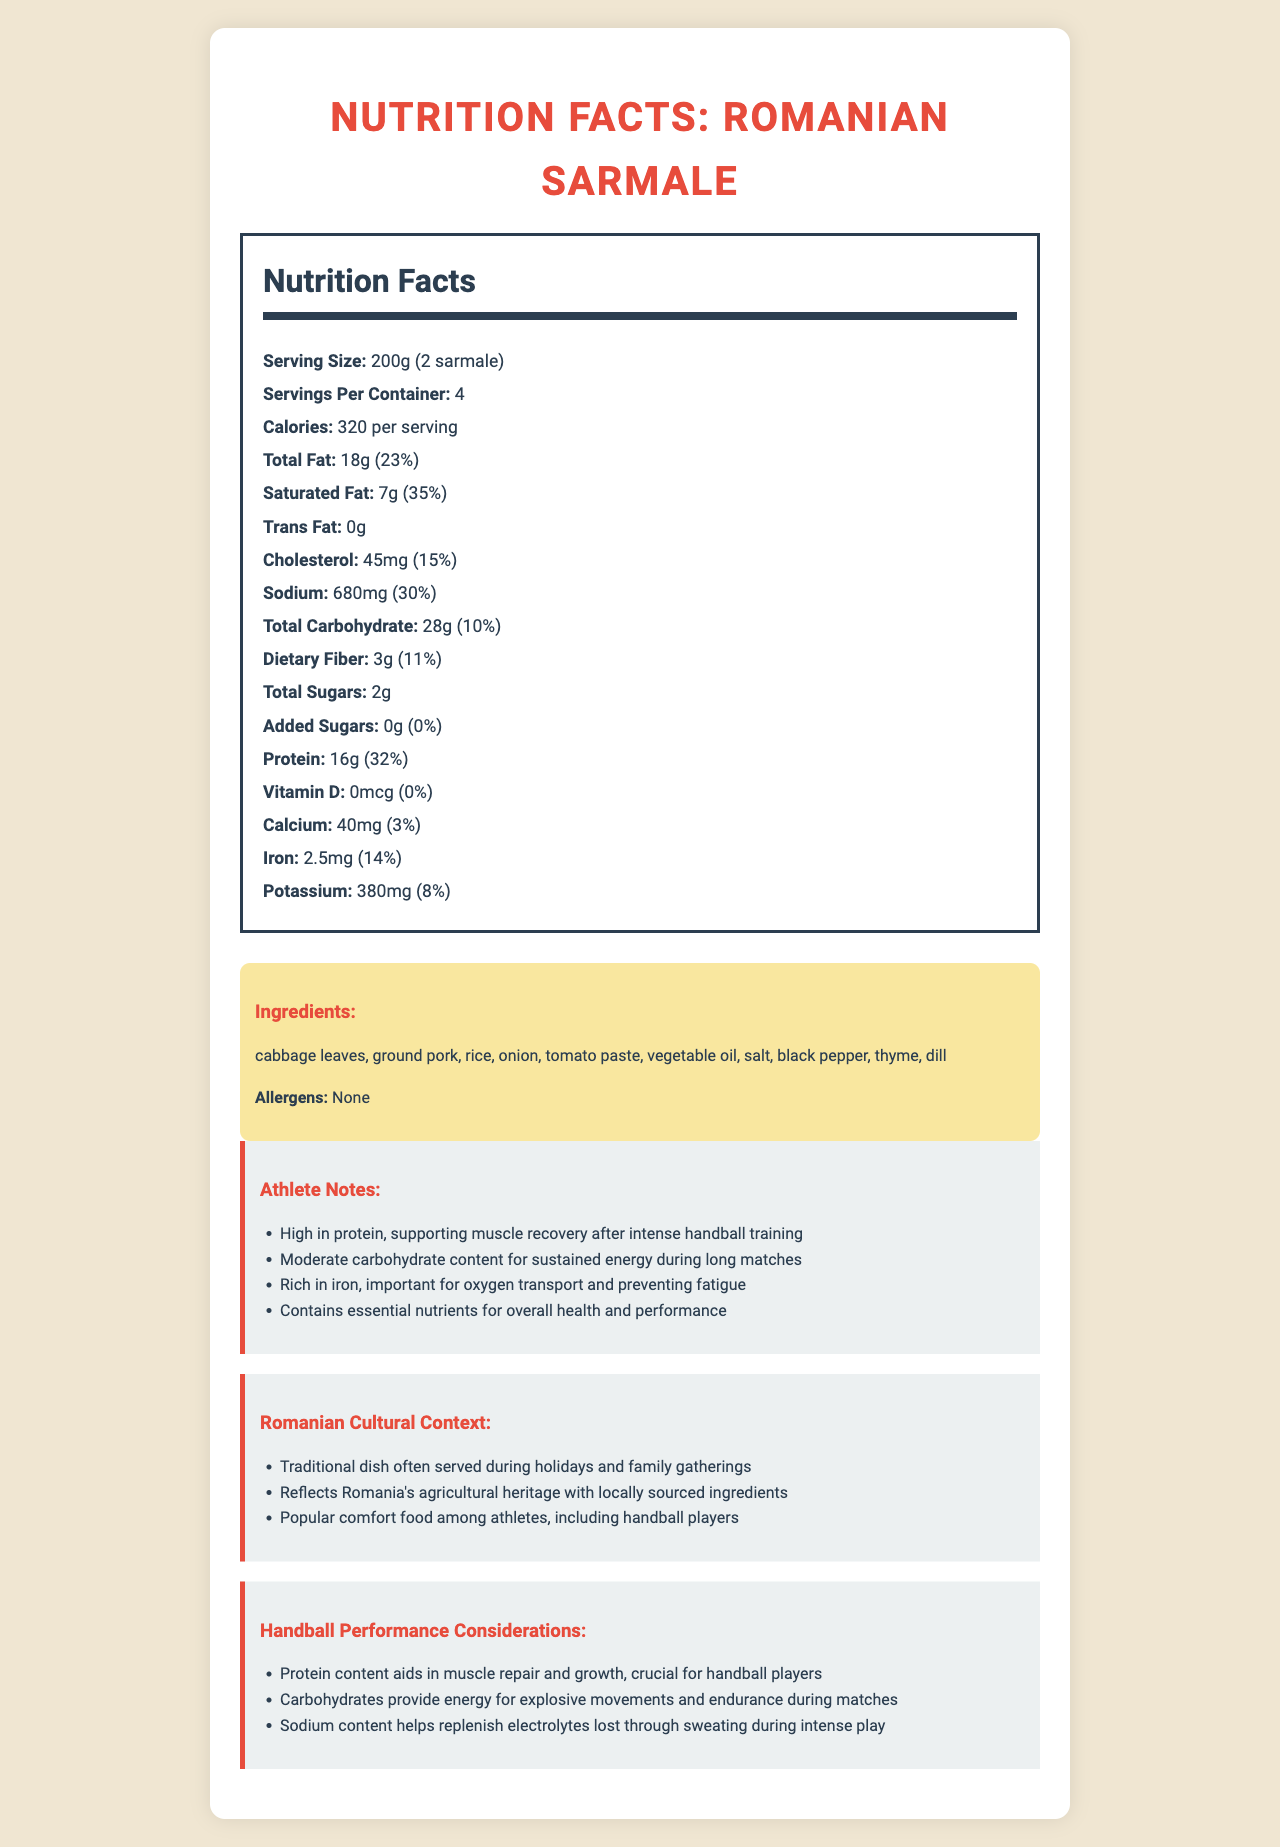what is the serving size for the sarmale dish? The document states that the serving size is 200g, which is equivalent to 2 sarmale.
Answer: 200g (2 sarmale) how much protein does one serving of the sarmale dish contain? The document specifically lists that one serving of the sarmale dish contains 16g of protein.
Answer: 16g What is the total carbohydrate content per serving? The document indicates that the total carbohydrate content per serving is 28g.
Answer: 28g what percentage of the daily value (%DV) for carbohydrates does one serving provide? The document states that the total carbohydrate content per serving contributes to 10% of the daily value.
Answer: 10% how much dietary fiber is present in one serving of the sarmale dish? The dietary fiber content per serving is listed as 3g in the document.
Answer: 3g what are the primary ingredients in the traditional Romanian sarmale dish? The document lists the primary ingredients as cabbage leaves, ground pork, rice, onion, tomato paste, vegetable oil, salt, black pepper, thyme, and dill.
Answer: cabbage leaves, ground pork, rice, onion, tomato paste, vegetable oil, salt, black pepper, thyme, dill how does the protein content of the sarmale dish benefit handball players? According to the document, the high protein content aids in muscle repair and growth, crucial for handball players.
Answer: supports muscle recovery and growth Which nutrient is important for preventing fatigue and is found in the sarmale dish? A. Vitamin D B. Iron C. Calcium D. Potassium Iron is listed as being important for oxygen transport and preventing fatigue, which is crucial for athletes.
Answer: B How many servings are contained per container of the sarmale dish? A. 2 B. 4 C. 6 D. 8 The document indicates that there are 4 servings per container of the sarmale dish.
Answer: B Does the sarmale dish contain any added sugars? The document specifically notes that the sarmale dish contains 0g of added sugars.
Answer: No Summarize the benefits of the traditional Romanian sarmale dish for a professional handball player. The document details various benefits of the sarmale dish for handball players, focusing on protein for muscle recovery, carbohydrates for energy, iron for oxygen transport, and sodium for electrolyte replenishment.
Answer: The sarmale dish is high in protein, which supports muscle recovery after intense training. It contains moderate carbohydrate content, providing sustained energy for long matches. Iron in the dish aids oxygen transport and helps prevent fatigue. Additionally, the sodium content helps replenish electrolytes lost through sweating. Overall, it contains essential nutrients beneficial for health and athletic performance. What are the daily percentages for fat, sodium, and protein provided by one serving of sarmale? The document lists the daily percentages of fat as 23%, sodium as 30%, and protein as 32% for one serving.
Answer: Total Fat: 23%, Sodium: 30%, Protein: 32% What traditional aspect does the sarmale dish reflect in Romanian culture? The document highlights that the traditional sarmale dish reflects Romania's agricultural heritage through the use of locally sourced ingredients.
Answer: Reflects Romania's agricultural heritage with locally sourced ingredients What is the specific calorie content per serving of the sarmale dish? The document states that each serving contains 320 calories.
Answer: 320 calories Can you determine the vitamin D content in the sarmale dish? The document lists the vitamin D content explicitly as 0mcg.
Answer: 0mcg How many grams of saturated fat are in one serving, and what is its daily value percentage? The document states that one serving contains 7g of saturated fat, which is 35% of the daily value.
Answer: 7g, 35% Is the allergen information specified in the document for the sarmale dish? The document specifies that there are no allergens present in the sarmale dish.
Answer: Yes, None 